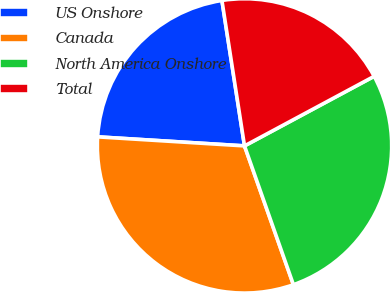Convert chart. <chart><loc_0><loc_0><loc_500><loc_500><pie_chart><fcel>US Onshore<fcel>Canada<fcel>North America Onshore<fcel>Total<nl><fcel>21.57%<fcel>31.37%<fcel>27.45%<fcel>19.61%<nl></chart> 